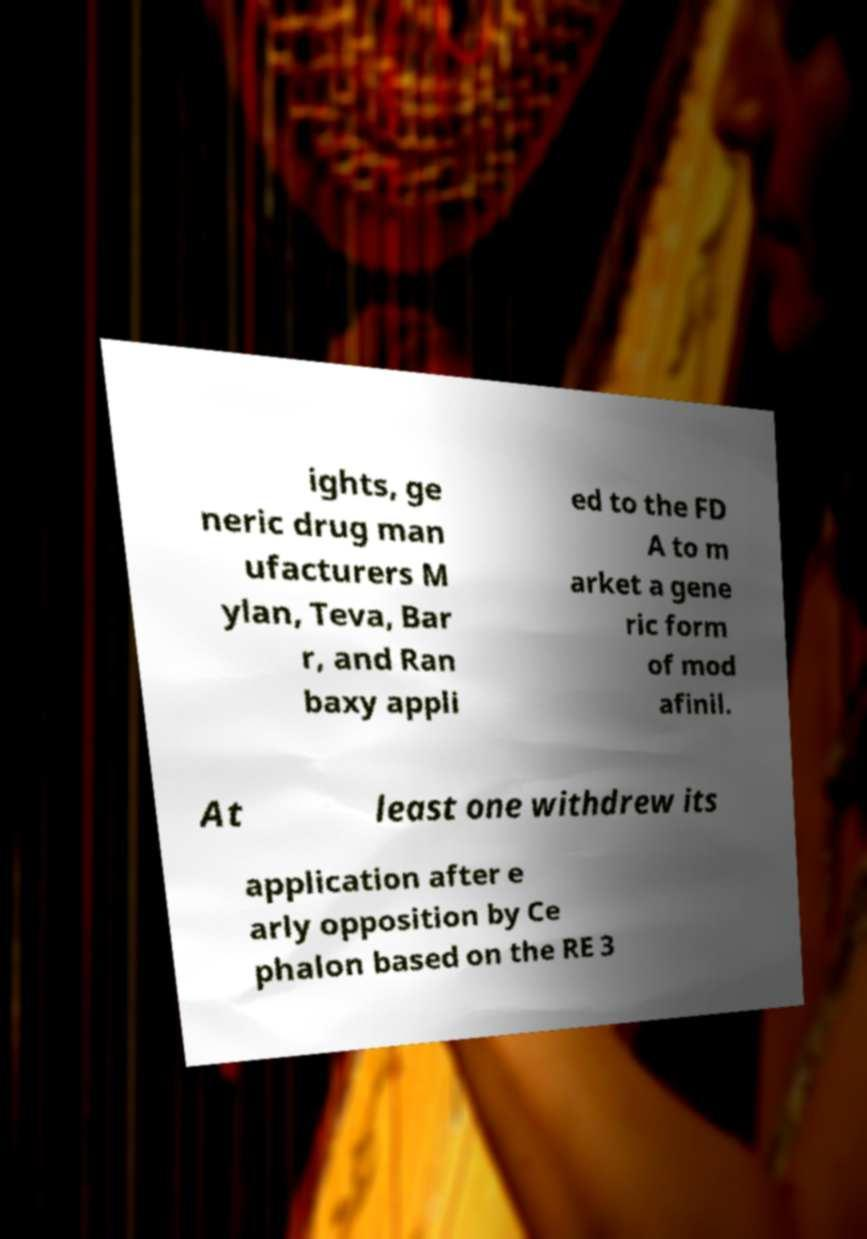What messages or text are displayed in this image? I need them in a readable, typed format. ights, ge neric drug man ufacturers M ylan, Teva, Bar r, and Ran baxy appli ed to the FD A to m arket a gene ric form of mod afinil. At least one withdrew its application after e arly opposition by Ce phalon based on the RE 3 